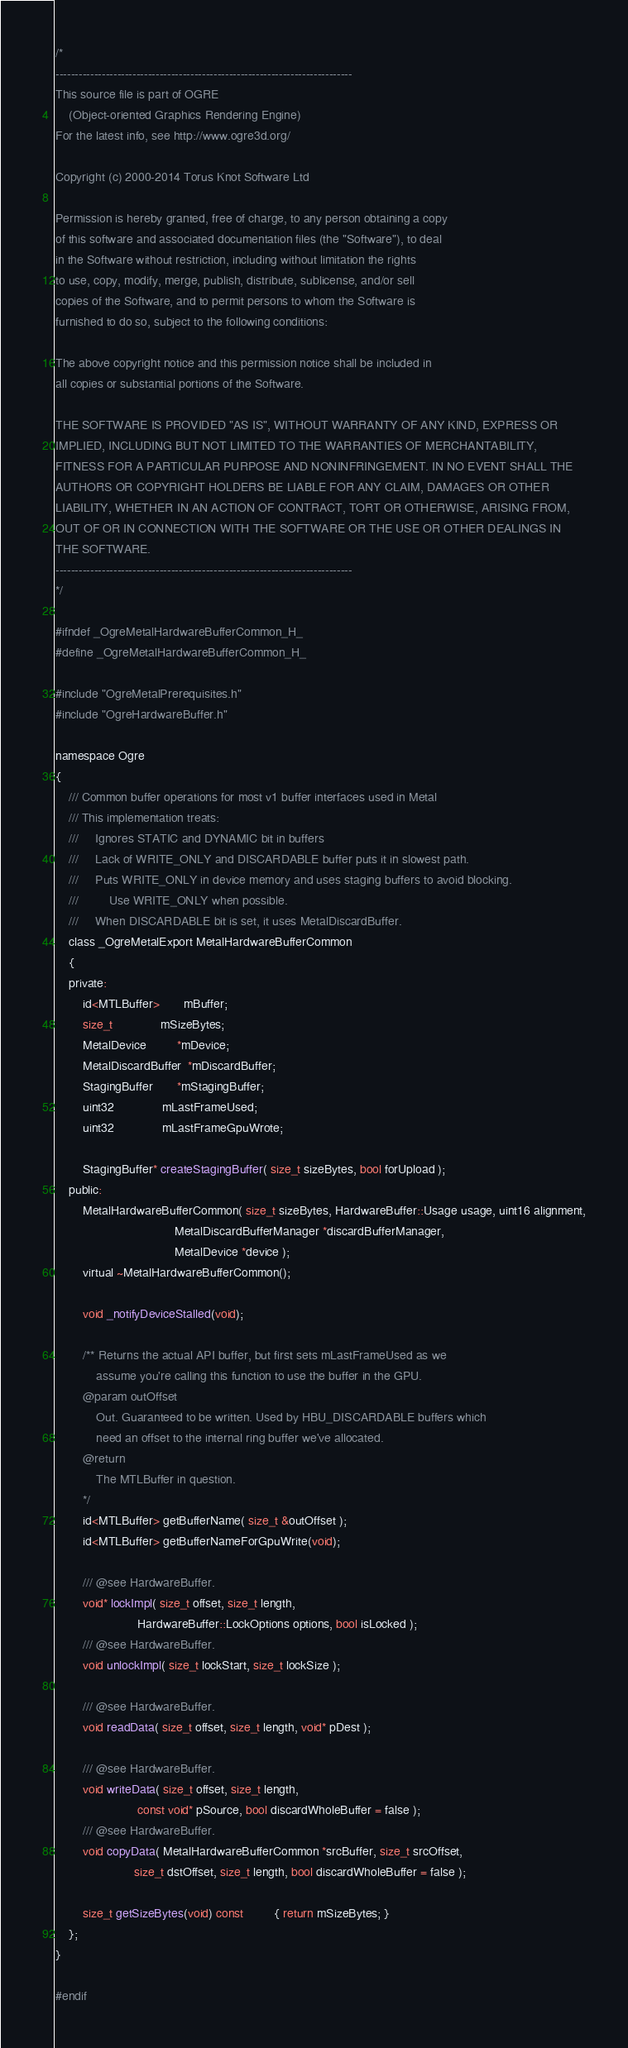Convert code to text. <code><loc_0><loc_0><loc_500><loc_500><_C_>/*
-----------------------------------------------------------------------------
This source file is part of OGRE
    (Object-oriented Graphics Rendering Engine)
For the latest info, see http://www.ogre3d.org/

Copyright (c) 2000-2014 Torus Knot Software Ltd

Permission is hereby granted, free of charge, to any person obtaining a copy
of this software and associated documentation files (the "Software"), to deal
in the Software without restriction, including without limitation the rights
to use, copy, modify, merge, publish, distribute, sublicense, and/or sell
copies of the Software, and to permit persons to whom the Software is
furnished to do so, subject to the following conditions:

The above copyright notice and this permission notice shall be included in
all copies or substantial portions of the Software.

THE SOFTWARE IS PROVIDED "AS IS", WITHOUT WARRANTY OF ANY KIND, EXPRESS OR
IMPLIED, INCLUDING BUT NOT LIMITED TO THE WARRANTIES OF MERCHANTABILITY,
FITNESS FOR A PARTICULAR PURPOSE AND NONINFRINGEMENT. IN NO EVENT SHALL THE
AUTHORS OR COPYRIGHT HOLDERS BE LIABLE FOR ANY CLAIM, DAMAGES OR OTHER
LIABILITY, WHETHER IN AN ACTION OF CONTRACT, TORT OR OTHERWISE, ARISING FROM,
OUT OF OR IN CONNECTION WITH THE SOFTWARE OR THE USE OR OTHER DEALINGS IN
THE SOFTWARE.
-----------------------------------------------------------------------------
*/

#ifndef _OgreMetalHardwareBufferCommon_H_
#define _OgreMetalHardwareBufferCommon_H_

#include "OgreMetalPrerequisites.h"
#include "OgreHardwareBuffer.h"

namespace Ogre
{
    /// Common buffer operations for most v1 buffer interfaces used in Metal
    /// This implementation treats:
    ///		Ignores STATIC and DYNAMIC bit in buffers
    ///		Lack of WRITE_ONLY and DISCARDABLE buffer puts it in slowest path.
    ///		Puts WRITE_ONLY in device memory and uses staging buffers to avoid blocking.
    ///			Use WRITE_ONLY when possible.
    ///		When DISCARDABLE bit is set, it uses MetalDiscardBuffer.
    class _OgreMetalExport MetalHardwareBufferCommon
    {
    private:
        id<MTLBuffer>       mBuffer;
        size_t              mSizeBytes;
        MetalDevice         *mDevice;
        MetalDiscardBuffer  *mDiscardBuffer;
        StagingBuffer       *mStagingBuffer;
        uint32              mLastFrameUsed;
        uint32              mLastFrameGpuWrote;

        StagingBuffer* createStagingBuffer( size_t sizeBytes, bool forUpload );
    public:
        MetalHardwareBufferCommon( size_t sizeBytes, HardwareBuffer::Usage usage, uint16 alignment,
                                   MetalDiscardBufferManager *discardBufferManager,
                                   MetalDevice *device );
        virtual ~MetalHardwareBufferCommon();

        void _notifyDeviceStalled(void);

        /** Returns the actual API buffer, but first sets mLastFrameUsed as we
            assume you're calling this function to use the buffer in the GPU.
        @param outOffset
            Out. Guaranteed to be written. Used by HBU_DISCARDABLE buffers which
            need an offset to the internal ring buffer we've allocated.
        @return
            The MTLBuffer in question.
        */
        id<MTLBuffer> getBufferName( size_t &outOffset );
        id<MTLBuffer> getBufferNameForGpuWrite(void);

        /// @see HardwareBuffer.
        void* lockImpl( size_t offset, size_t length,
                        HardwareBuffer::LockOptions options, bool isLocked );
        /// @see HardwareBuffer.
        void unlockImpl( size_t lockStart, size_t lockSize );

        /// @see HardwareBuffer.
        void readData( size_t offset, size_t length, void* pDest );

        /// @see HardwareBuffer.
        void writeData( size_t offset, size_t length,
                        const void* pSource, bool discardWholeBuffer = false );
        /// @see HardwareBuffer.
        void copyData( MetalHardwareBufferCommon *srcBuffer, size_t srcOffset,
                       size_t dstOffset, size_t length, bool discardWholeBuffer = false );

        size_t getSizeBytes(void) const         { return mSizeBytes; }
    };
}

#endif
</code> 